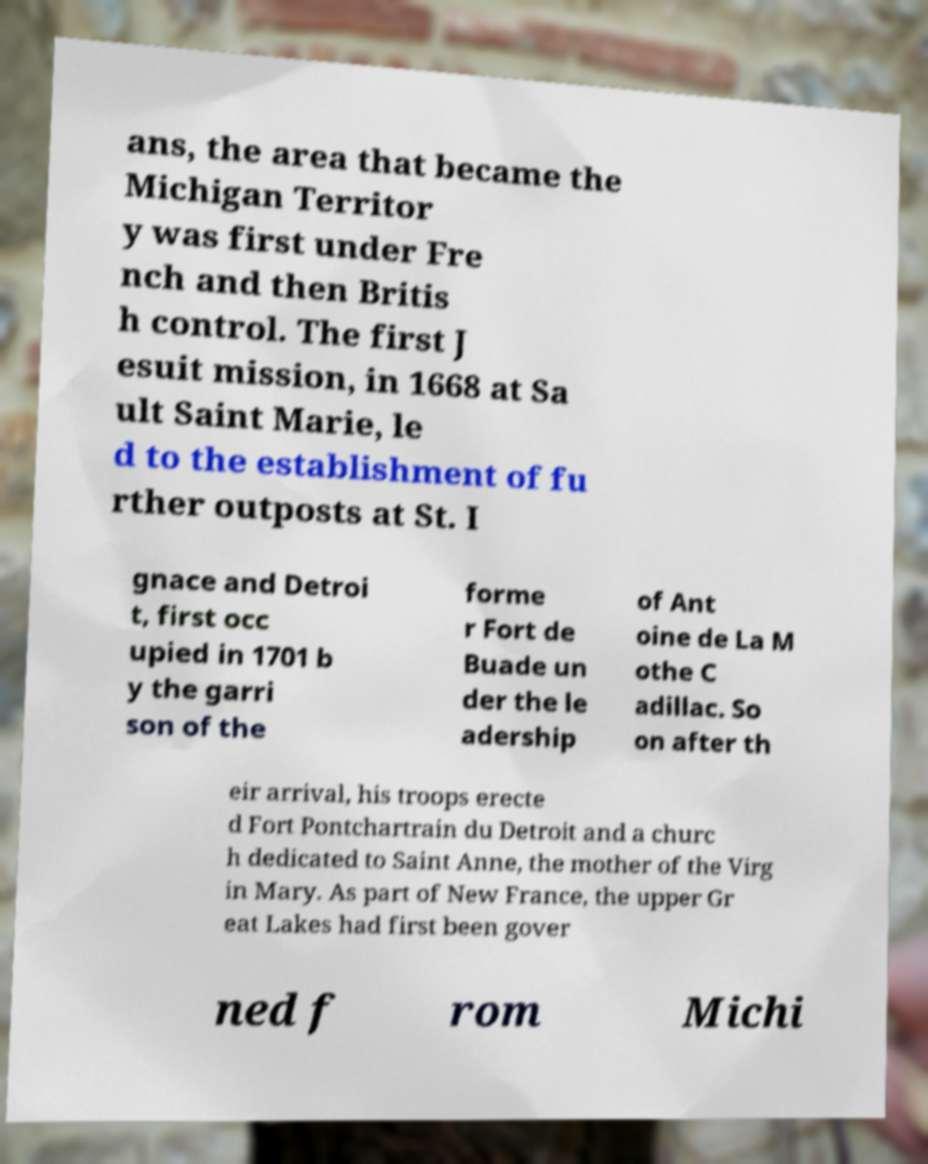There's text embedded in this image that I need extracted. Can you transcribe it verbatim? ans, the area that became the Michigan Territor y was first under Fre nch and then Britis h control. The first J esuit mission, in 1668 at Sa ult Saint Marie, le d to the establishment of fu rther outposts at St. I gnace and Detroi t, first occ upied in 1701 b y the garri son of the forme r Fort de Buade un der the le adership of Ant oine de La M othe C adillac. So on after th eir arrival, his troops erecte d Fort Pontchartrain du Detroit and a churc h dedicated to Saint Anne, the mother of the Virg in Mary. As part of New France, the upper Gr eat Lakes had first been gover ned f rom Michi 